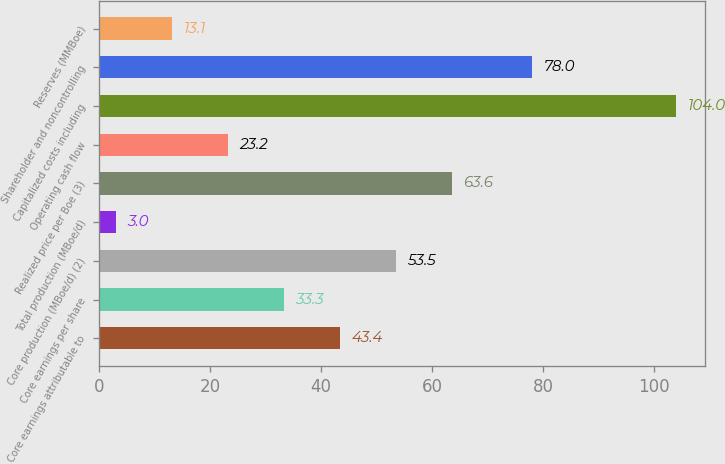<chart> <loc_0><loc_0><loc_500><loc_500><bar_chart><fcel>Core earnings attributable to<fcel>Core earnings per share<fcel>Core production (MBoe/d) (2)<fcel>Total production (MBoe/d)<fcel>Realized price per Boe (3)<fcel>Operating cash flow<fcel>Capitalized costs including<fcel>Shareholder and noncontrolling<fcel>Reserves (MMBoe)<nl><fcel>43.4<fcel>33.3<fcel>53.5<fcel>3<fcel>63.6<fcel>23.2<fcel>104<fcel>78<fcel>13.1<nl></chart> 